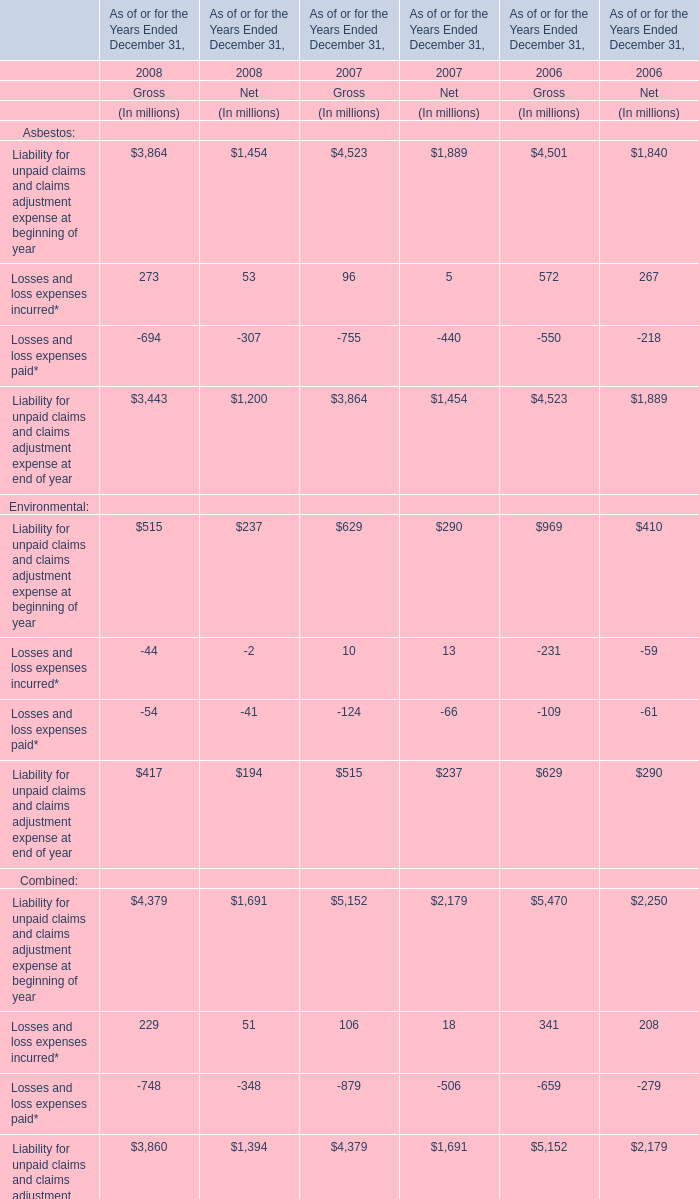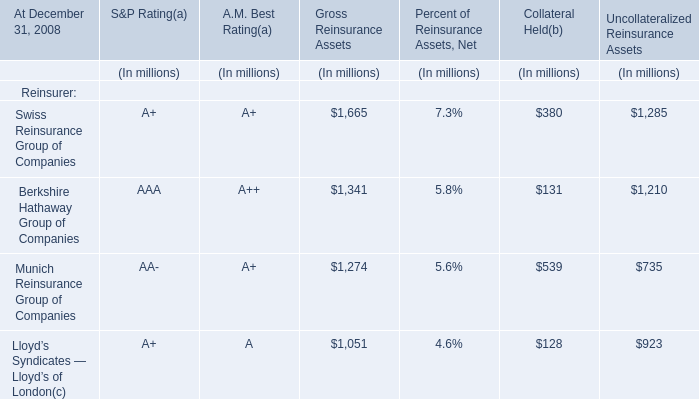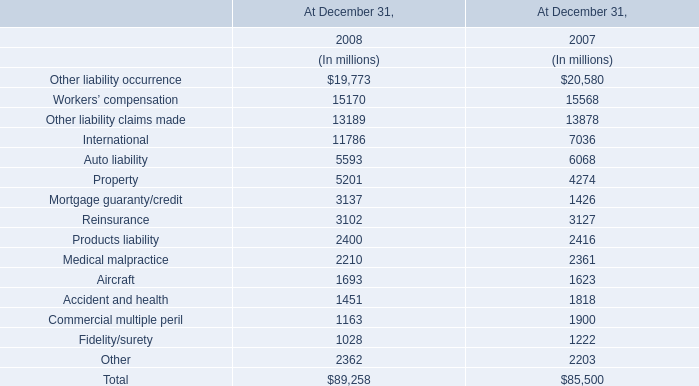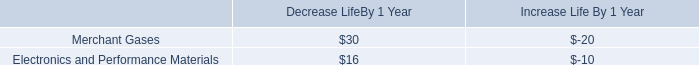what is the depreciation expense with the production facilities within the electronics and performance materials segment accumulated in 10 years? 
Computations: (10 * 10)
Answer: 100.0. 